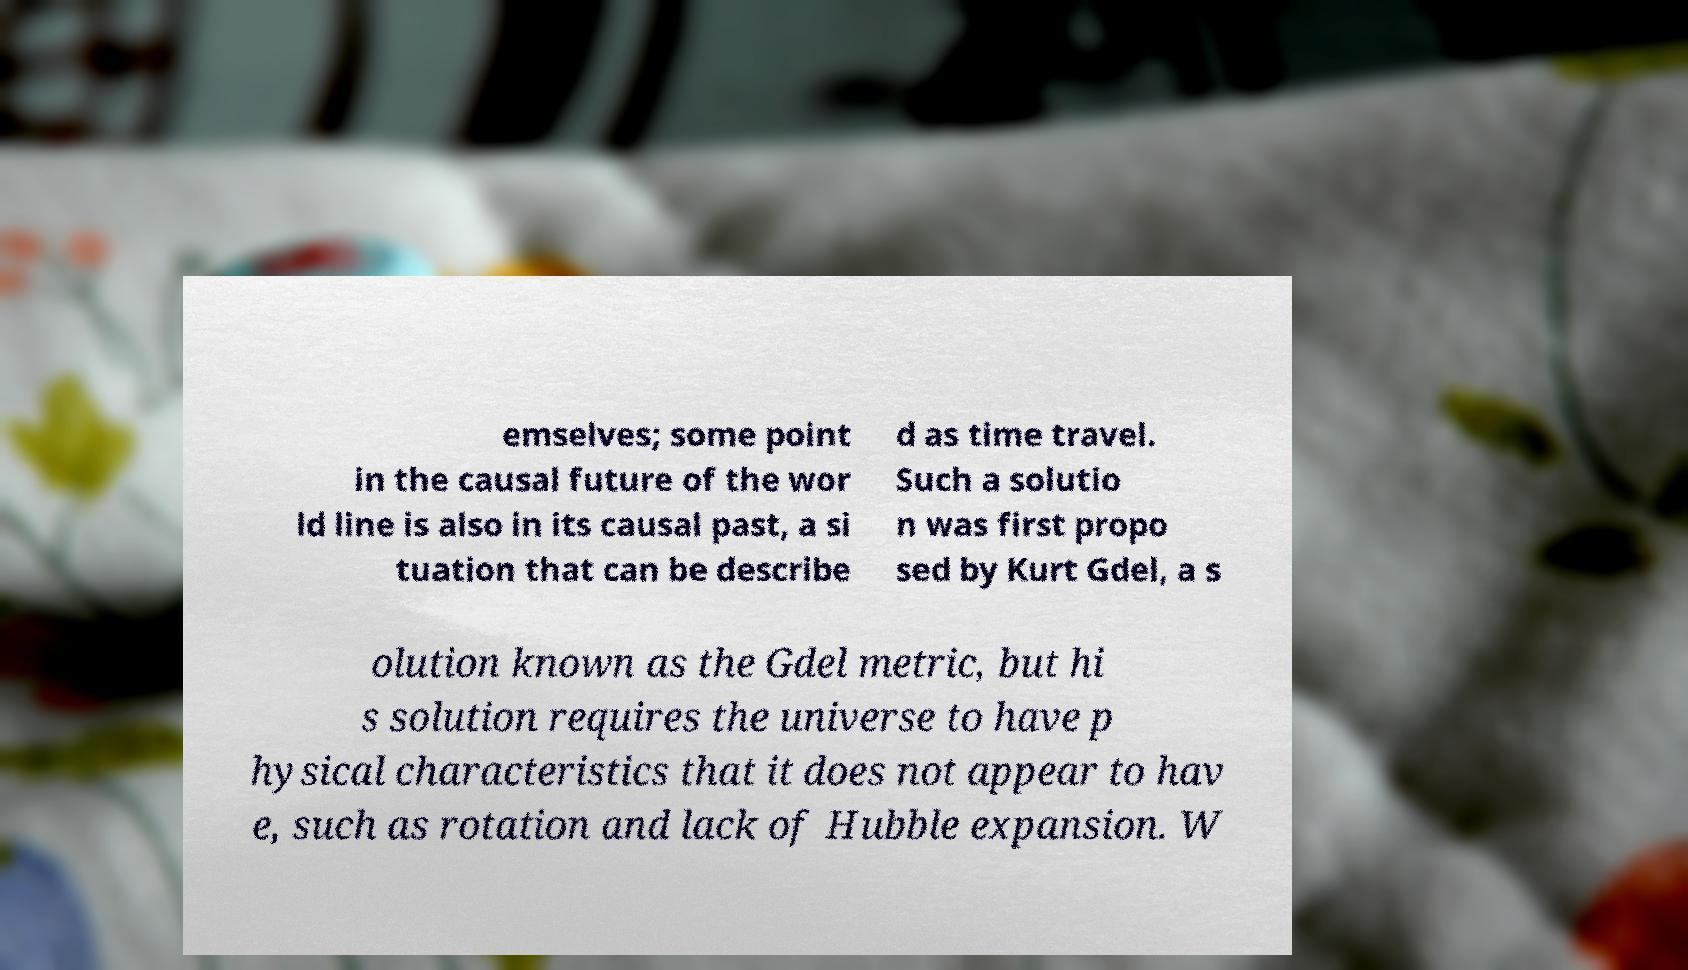Can you accurately transcribe the text from the provided image for me? emselves; some point in the causal future of the wor ld line is also in its causal past, a si tuation that can be describe d as time travel. Such a solutio n was first propo sed by Kurt Gdel, a s olution known as the Gdel metric, but hi s solution requires the universe to have p hysical characteristics that it does not appear to hav e, such as rotation and lack of Hubble expansion. W 